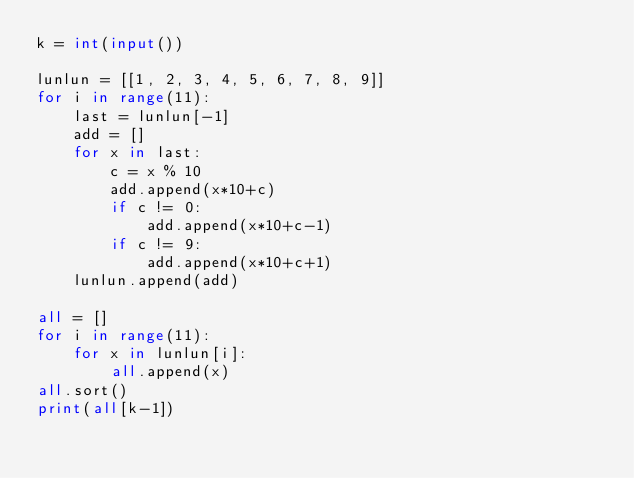Convert code to text. <code><loc_0><loc_0><loc_500><loc_500><_Python_>k = int(input())

lunlun = [[1, 2, 3, 4, 5, 6, 7, 8, 9]]
for i in range(11):
    last = lunlun[-1]
    add = []
    for x in last:
        c = x % 10
        add.append(x*10+c)
        if c != 0:
            add.append(x*10+c-1)
        if c != 9:
            add.append(x*10+c+1)
    lunlun.append(add)

all = []
for i in range(11):
    for x in lunlun[i]:
        all.append(x)
all.sort()
print(all[k-1])
</code> 